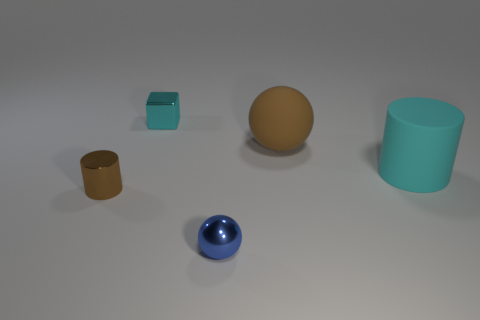How big is the cyan rubber thing?
Provide a succinct answer. Large. There is a cylinder in front of the large cylinder; what number of cyan blocks are in front of it?
Ensure brevity in your answer.  0. There is a object that is on the right side of the blue metallic object and on the left side of the large cyan rubber cylinder; what is its shape?
Offer a terse response. Sphere. What number of large objects have the same color as the tiny metallic block?
Ensure brevity in your answer.  1. Are there any tiny cyan metal objects in front of the cylinder behind the cylinder left of the metallic sphere?
Your response must be concise. No. How big is the thing that is in front of the brown rubber sphere and behind the brown cylinder?
Your answer should be compact. Large. How many small cyan objects are the same material as the tiny brown object?
Your answer should be compact. 1. What number of cylinders are either shiny objects or big cyan matte things?
Keep it short and to the point. 2. There is a ball that is on the right side of the shiny object in front of the brown object that is left of the brown matte object; how big is it?
Offer a terse response. Large. There is a tiny object that is behind the blue ball and in front of the big brown matte sphere; what is its color?
Provide a short and direct response. Brown. 